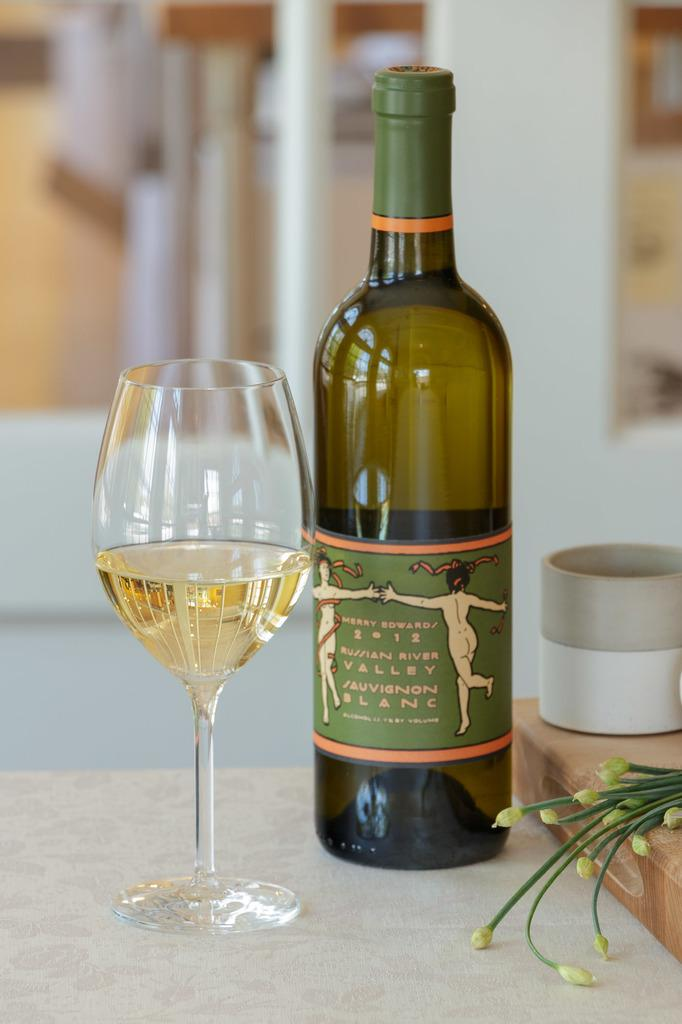<image>
Relay a brief, clear account of the picture shown. A wine bottle with the label Mary Edwards 2012 Russian River Valley Sauvignon Blanc  and a filled wine glass beside it. 